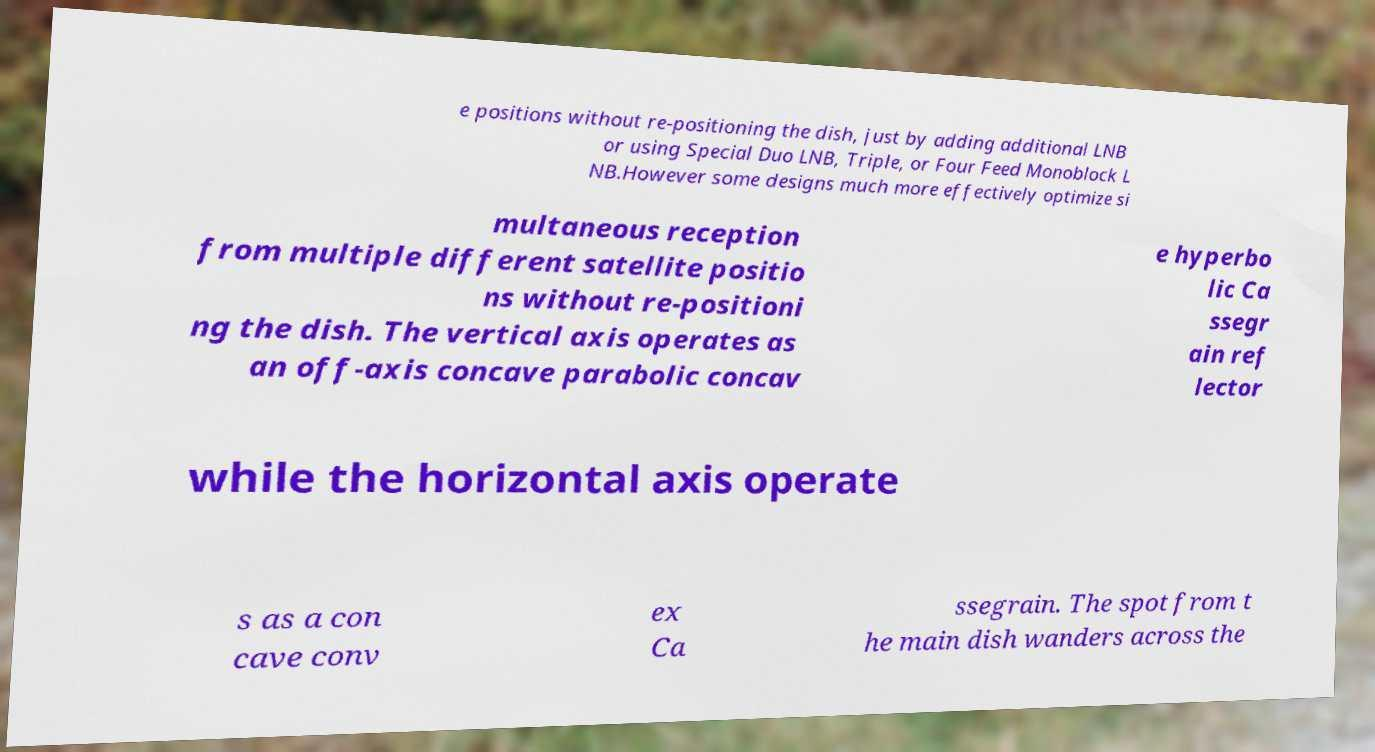What messages or text are displayed in this image? I need them in a readable, typed format. e positions without re-positioning the dish, just by adding additional LNB or using Special Duo LNB, Triple, or Four Feed Monoblock L NB.However some designs much more effectively optimize si multaneous reception from multiple different satellite positio ns without re-positioni ng the dish. The vertical axis operates as an off-axis concave parabolic concav e hyperbo lic Ca ssegr ain ref lector while the horizontal axis operate s as a con cave conv ex Ca ssegrain. The spot from t he main dish wanders across the 